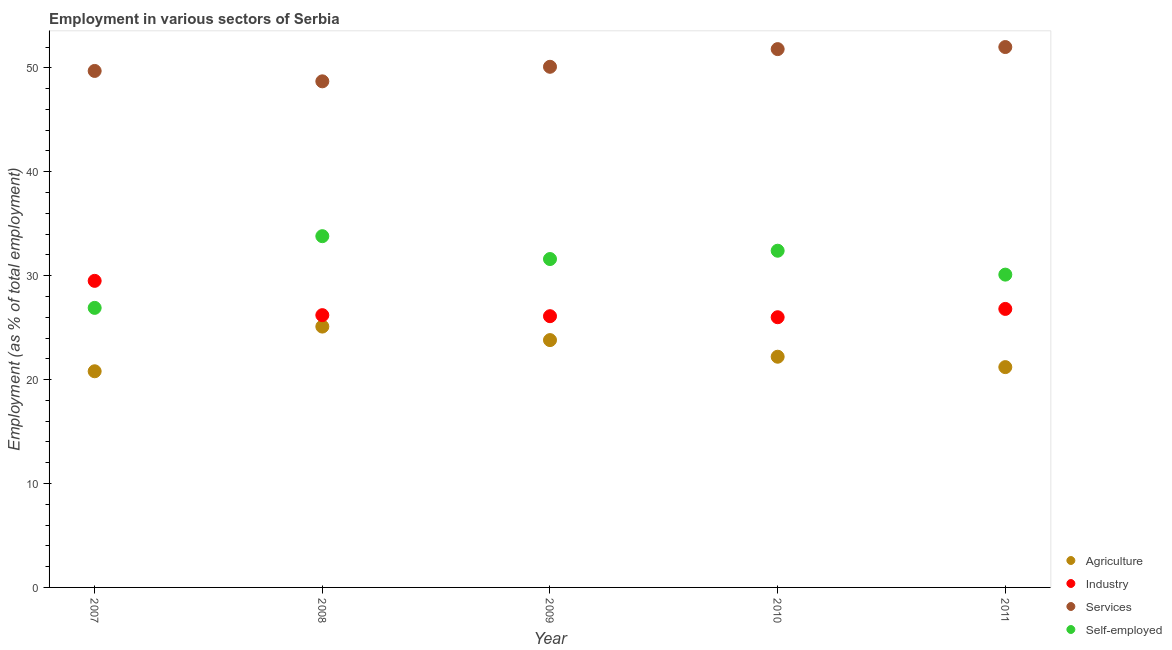How many different coloured dotlines are there?
Ensure brevity in your answer.  4. What is the percentage of workers in services in 2010?
Your response must be concise. 51.8. Across all years, what is the maximum percentage of self employed workers?
Make the answer very short. 33.8. In which year was the percentage of self employed workers maximum?
Offer a very short reply. 2008. What is the total percentage of workers in industry in the graph?
Ensure brevity in your answer.  134.6. What is the difference between the percentage of self employed workers in 2008 and that in 2010?
Your answer should be compact. 1.4. What is the difference between the percentage of workers in industry in 2011 and the percentage of workers in services in 2007?
Make the answer very short. -22.9. What is the average percentage of self employed workers per year?
Offer a very short reply. 30.96. In the year 2010, what is the difference between the percentage of workers in services and percentage of workers in agriculture?
Your answer should be very brief. 29.6. What is the ratio of the percentage of workers in agriculture in 2009 to that in 2010?
Your answer should be very brief. 1.07. What is the difference between the highest and the second highest percentage of self employed workers?
Make the answer very short. 1.4. What is the difference between the highest and the lowest percentage of workers in services?
Your response must be concise. 3.3. In how many years, is the percentage of workers in agriculture greater than the average percentage of workers in agriculture taken over all years?
Your answer should be very brief. 2. Is the sum of the percentage of self employed workers in 2010 and 2011 greater than the maximum percentage of workers in industry across all years?
Offer a terse response. Yes. Is it the case that in every year, the sum of the percentage of workers in services and percentage of workers in industry is greater than the sum of percentage of self employed workers and percentage of workers in agriculture?
Provide a succinct answer. No. Is it the case that in every year, the sum of the percentage of workers in agriculture and percentage of workers in industry is greater than the percentage of workers in services?
Ensure brevity in your answer.  No. Is the percentage of self employed workers strictly greater than the percentage of workers in services over the years?
Provide a succinct answer. No. Is the percentage of workers in industry strictly less than the percentage of workers in services over the years?
Offer a terse response. Yes. How many dotlines are there?
Your answer should be compact. 4. How many years are there in the graph?
Ensure brevity in your answer.  5. How many legend labels are there?
Provide a succinct answer. 4. What is the title of the graph?
Offer a terse response. Employment in various sectors of Serbia. Does "Secondary vocational education" appear as one of the legend labels in the graph?
Provide a short and direct response. No. What is the label or title of the Y-axis?
Make the answer very short. Employment (as % of total employment). What is the Employment (as % of total employment) of Agriculture in 2007?
Provide a succinct answer. 20.8. What is the Employment (as % of total employment) in Industry in 2007?
Keep it short and to the point. 29.5. What is the Employment (as % of total employment) in Services in 2007?
Offer a very short reply. 49.7. What is the Employment (as % of total employment) in Self-employed in 2007?
Offer a very short reply. 26.9. What is the Employment (as % of total employment) of Agriculture in 2008?
Keep it short and to the point. 25.1. What is the Employment (as % of total employment) of Industry in 2008?
Offer a terse response. 26.2. What is the Employment (as % of total employment) of Services in 2008?
Ensure brevity in your answer.  48.7. What is the Employment (as % of total employment) of Self-employed in 2008?
Keep it short and to the point. 33.8. What is the Employment (as % of total employment) of Agriculture in 2009?
Your response must be concise. 23.8. What is the Employment (as % of total employment) in Industry in 2009?
Provide a short and direct response. 26.1. What is the Employment (as % of total employment) in Services in 2009?
Give a very brief answer. 50.1. What is the Employment (as % of total employment) in Self-employed in 2009?
Your answer should be compact. 31.6. What is the Employment (as % of total employment) in Agriculture in 2010?
Provide a short and direct response. 22.2. What is the Employment (as % of total employment) of Industry in 2010?
Your answer should be very brief. 26. What is the Employment (as % of total employment) of Services in 2010?
Offer a terse response. 51.8. What is the Employment (as % of total employment) of Self-employed in 2010?
Your response must be concise. 32.4. What is the Employment (as % of total employment) in Agriculture in 2011?
Give a very brief answer. 21.2. What is the Employment (as % of total employment) of Industry in 2011?
Your answer should be very brief. 26.8. What is the Employment (as % of total employment) in Services in 2011?
Make the answer very short. 52. What is the Employment (as % of total employment) of Self-employed in 2011?
Keep it short and to the point. 30.1. Across all years, what is the maximum Employment (as % of total employment) in Agriculture?
Provide a short and direct response. 25.1. Across all years, what is the maximum Employment (as % of total employment) of Industry?
Provide a short and direct response. 29.5. Across all years, what is the maximum Employment (as % of total employment) of Self-employed?
Give a very brief answer. 33.8. Across all years, what is the minimum Employment (as % of total employment) in Agriculture?
Ensure brevity in your answer.  20.8. Across all years, what is the minimum Employment (as % of total employment) of Industry?
Make the answer very short. 26. Across all years, what is the minimum Employment (as % of total employment) in Services?
Provide a short and direct response. 48.7. Across all years, what is the minimum Employment (as % of total employment) in Self-employed?
Give a very brief answer. 26.9. What is the total Employment (as % of total employment) in Agriculture in the graph?
Your answer should be very brief. 113.1. What is the total Employment (as % of total employment) in Industry in the graph?
Give a very brief answer. 134.6. What is the total Employment (as % of total employment) in Services in the graph?
Give a very brief answer. 252.3. What is the total Employment (as % of total employment) in Self-employed in the graph?
Make the answer very short. 154.8. What is the difference between the Employment (as % of total employment) of Services in 2007 and that in 2008?
Offer a very short reply. 1. What is the difference between the Employment (as % of total employment) of Self-employed in 2007 and that in 2008?
Provide a short and direct response. -6.9. What is the difference between the Employment (as % of total employment) in Industry in 2007 and that in 2010?
Ensure brevity in your answer.  3.5. What is the difference between the Employment (as % of total employment) of Self-employed in 2007 and that in 2010?
Your response must be concise. -5.5. What is the difference between the Employment (as % of total employment) in Services in 2007 and that in 2011?
Offer a terse response. -2.3. What is the difference between the Employment (as % of total employment) of Services in 2008 and that in 2009?
Ensure brevity in your answer.  -1.4. What is the difference between the Employment (as % of total employment) of Agriculture in 2008 and that in 2010?
Ensure brevity in your answer.  2.9. What is the difference between the Employment (as % of total employment) in Self-employed in 2008 and that in 2010?
Provide a short and direct response. 1.4. What is the difference between the Employment (as % of total employment) in Agriculture in 2008 and that in 2011?
Provide a short and direct response. 3.9. What is the difference between the Employment (as % of total employment) in Industry in 2008 and that in 2011?
Provide a succinct answer. -0.6. What is the difference between the Employment (as % of total employment) of Self-employed in 2008 and that in 2011?
Provide a succinct answer. 3.7. What is the difference between the Employment (as % of total employment) of Agriculture in 2009 and that in 2010?
Offer a very short reply. 1.6. What is the difference between the Employment (as % of total employment) in Services in 2009 and that in 2010?
Provide a succinct answer. -1.7. What is the difference between the Employment (as % of total employment) in Self-employed in 2009 and that in 2010?
Keep it short and to the point. -0.8. What is the difference between the Employment (as % of total employment) of Agriculture in 2009 and that in 2011?
Offer a terse response. 2.6. What is the difference between the Employment (as % of total employment) of Industry in 2009 and that in 2011?
Your answer should be compact. -0.7. What is the difference between the Employment (as % of total employment) of Self-employed in 2009 and that in 2011?
Keep it short and to the point. 1.5. What is the difference between the Employment (as % of total employment) in Industry in 2010 and that in 2011?
Ensure brevity in your answer.  -0.8. What is the difference between the Employment (as % of total employment) of Services in 2010 and that in 2011?
Your response must be concise. -0.2. What is the difference between the Employment (as % of total employment) in Agriculture in 2007 and the Employment (as % of total employment) in Industry in 2008?
Provide a succinct answer. -5.4. What is the difference between the Employment (as % of total employment) of Agriculture in 2007 and the Employment (as % of total employment) of Services in 2008?
Provide a short and direct response. -27.9. What is the difference between the Employment (as % of total employment) in Agriculture in 2007 and the Employment (as % of total employment) in Self-employed in 2008?
Your response must be concise. -13. What is the difference between the Employment (as % of total employment) in Industry in 2007 and the Employment (as % of total employment) in Services in 2008?
Provide a short and direct response. -19.2. What is the difference between the Employment (as % of total employment) in Industry in 2007 and the Employment (as % of total employment) in Self-employed in 2008?
Ensure brevity in your answer.  -4.3. What is the difference between the Employment (as % of total employment) of Services in 2007 and the Employment (as % of total employment) of Self-employed in 2008?
Your response must be concise. 15.9. What is the difference between the Employment (as % of total employment) of Agriculture in 2007 and the Employment (as % of total employment) of Services in 2009?
Provide a short and direct response. -29.3. What is the difference between the Employment (as % of total employment) in Industry in 2007 and the Employment (as % of total employment) in Services in 2009?
Your answer should be very brief. -20.6. What is the difference between the Employment (as % of total employment) in Industry in 2007 and the Employment (as % of total employment) in Self-employed in 2009?
Your response must be concise. -2.1. What is the difference between the Employment (as % of total employment) in Services in 2007 and the Employment (as % of total employment) in Self-employed in 2009?
Ensure brevity in your answer.  18.1. What is the difference between the Employment (as % of total employment) in Agriculture in 2007 and the Employment (as % of total employment) in Services in 2010?
Ensure brevity in your answer.  -31. What is the difference between the Employment (as % of total employment) in Industry in 2007 and the Employment (as % of total employment) in Services in 2010?
Provide a succinct answer. -22.3. What is the difference between the Employment (as % of total employment) in Industry in 2007 and the Employment (as % of total employment) in Self-employed in 2010?
Ensure brevity in your answer.  -2.9. What is the difference between the Employment (as % of total employment) of Services in 2007 and the Employment (as % of total employment) of Self-employed in 2010?
Your answer should be compact. 17.3. What is the difference between the Employment (as % of total employment) of Agriculture in 2007 and the Employment (as % of total employment) of Industry in 2011?
Offer a terse response. -6. What is the difference between the Employment (as % of total employment) in Agriculture in 2007 and the Employment (as % of total employment) in Services in 2011?
Your answer should be compact. -31.2. What is the difference between the Employment (as % of total employment) of Agriculture in 2007 and the Employment (as % of total employment) of Self-employed in 2011?
Ensure brevity in your answer.  -9.3. What is the difference between the Employment (as % of total employment) of Industry in 2007 and the Employment (as % of total employment) of Services in 2011?
Offer a terse response. -22.5. What is the difference between the Employment (as % of total employment) of Industry in 2007 and the Employment (as % of total employment) of Self-employed in 2011?
Ensure brevity in your answer.  -0.6. What is the difference between the Employment (as % of total employment) of Services in 2007 and the Employment (as % of total employment) of Self-employed in 2011?
Your answer should be very brief. 19.6. What is the difference between the Employment (as % of total employment) of Agriculture in 2008 and the Employment (as % of total employment) of Services in 2009?
Keep it short and to the point. -25. What is the difference between the Employment (as % of total employment) of Agriculture in 2008 and the Employment (as % of total employment) of Self-employed in 2009?
Offer a terse response. -6.5. What is the difference between the Employment (as % of total employment) in Industry in 2008 and the Employment (as % of total employment) in Services in 2009?
Ensure brevity in your answer.  -23.9. What is the difference between the Employment (as % of total employment) in Agriculture in 2008 and the Employment (as % of total employment) in Industry in 2010?
Provide a succinct answer. -0.9. What is the difference between the Employment (as % of total employment) of Agriculture in 2008 and the Employment (as % of total employment) of Services in 2010?
Keep it short and to the point. -26.7. What is the difference between the Employment (as % of total employment) in Industry in 2008 and the Employment (as % of total employment) in Services in 2010?
Ensure brevity in your answer.  -25.6. What is the difference between the Employment (as % of total employment) of Agriculture in 2008 and the Employment (as % of total employment) of Services in 2011?
Provide a short and direct response. -26.9. What is the difference between the Employment (as % of total employment) of Agriculture in 2008 and the Employment (as % of total employment) of Self-employed in 2011?
Your answer should be compact. -5. What is the difference between the Employment (as % of total employment) in Industry in 2008 and the Employment (as % of total employment) in Services in 2011?
Your answer should be compact. -25.8. What is the difference between the Employment (as % of total employment) of Services in 2008 and the Employment (as % of total employment) of Self-employed in 2011?
Your answer should be very brief. 18.6. What is the difference between the Employment (as % of total employment) of Industry in 2009 and the Employment (as % of total employment) of Services in 2010?
Keep it short and to the point. -25.7. What is the difference between the Employment (as % of total employment) in Agriculture in 2009 and the Employment (as % of total employment) in Industry in 2011?
Provide a succinct answer. -3. What is the difference between the Employment (as % of total employment) of Agriculture in 2009 and the Employment (as % of total employment) of Services in 2011?
Your answer should be compact. -28.2. What is the difference between the Employment (as % of total employment) in Agriculture in 2009 and the Employment (as % of total employment) in Self-employed in 2011?
Your answer should be compact. -6.3. What is the difference between the Employment (as % of total employment) of Industry in 2009 and the Employment (as % of total employment) of Services in 2011?
Provide a short and direct response. -25.9. What is the difference between the Employment (as % of total employment) of Agriculture in 2010 and the Employment (as % of total employment) of Industry in 2011?
Give a very brief answer. -4.6. What is the difference between the Employment (as % of total employment) of Agriculture in 2010 and the Employment (as % of total employment) of Services in 2011?
Your response must be concise. -29.8. What is the difference between the Employment (as % of total employment) of Industry in 2010 and the Employment (as % of total employment) of Self-employed in 2011?
Your response must be concise. -4.1. What is the difference between the Employment (as % of total employment) in Services in 2010 and the Employment (as % of total employment) in Self-employed in 2011?
Provide a succinct answer. 21.7. What is the average Employment (as % of total employment) of Agriculture per year?
Your answer should be very brief. 22.62. What is the average Employment (as % of total employment) of Industry per year?
Give a very brief answer. 26.92. What is the average Employment (as % of total employment) in Services per year?
Provide a short and direct response. 50.46. What is the average Employment (as % of total employment) of Self-employed per year?
Provide a short and direct response. 30.96. In the year 2007, what is the difference between the Employment (as % of total employment) of Agriculture and Employment (as % of total employment) of Services?
Make the answer very short. -28.9. In the year 2007, what is the difference between the Employment (as % of total employment) of Agriculture and Employment (as % of total employment) of Self-employed?
Ensure brevity in your answer.  -6.1. In the year 2007, what is the difference between the Employment (as % of total employment) in Industry and Employment (as % of total employment) in Services?
Offer a terse response. -20.2. In the year 2007, what is the difference between the Employment (as % of total employment) of Industry and Employment (as % of total employment) of Self-employed?
Your response must be concise. 2.6. In the year 2007, what is the difference between the Employment (as % of total employment) in Services and Employment (as % of total employment) in Self-employed?
Your answer should be compact. 22.8. In the year 2008, what is the difference between the Employment (as % of total employment) of Agriculture and Employment (as % of total employment) of Industry?
Your answer should be compact. -1.1. In the year 2008, what is the difference between the Employment (as % of total employment) in Agriculture and Employment (as % of total employment) in Services?
Keep it short and to the point. -23.6. In the year 2008, what is the difference between the Employment (as % of total employment) of Agriculture and Employment (as % of total employment) of Self-employed?
Provide a short and direct response. -8.7. In the year 2008, what is the difference between the Employment (as % of total employment) of Industry and Employment (as % of total employment) of Services?
Make the answer very short. -22.5. In the year 2008, what is the difference between the Employment (as % of total employment) of Industry and Employment (as % of total employment) of Self-employed?
Make the answer very short. -7.6. In the year 2008, what is the difference between the Employment (as % of total employment) of Services and Employment (as % of total employment) of Self-employed?
Keep it short and to the point. 14.9. In the year 2009, what is the difference between the Employment (as % of total employment) of Agriculture and Employment (as % of total employment) of Services?
Your response must be concise. -26.3. In the year 2010, what is the difference between the Employment (as % of total employment) of Agriculture and Employment (as % of total employment) of Industry?
Offer a very short reply. -3.8. In the year 2010, what is the difference between the Employment (as % of total employment) in Agriculture and Employment (as % of total employment) in Services?
Make the answer very short. -29.6. In the year 2010, what is the difference between the Employment (as % of total employment) in Agriculture and Employment (as % of total employment) in Self-employed?
Your answer should be compact. -10.2. In the year 2010, what is the difference between the Employment (as % of total employment) in Industry and Employment (as % of total employment) in Services?
Your response must be concise. -25.8. In the year 2010, what is the difference between the Employment (as % of total employment) in Industry and Employment (as % of total employment) in Self-employed?
Your response must be concise. -6.4. In the year 2010, what is the difference between the Employment (as % of total employment) in Services and Employment (as % of total employment) in Self-employed?
Make the answer very short. 19.4. In the year 2011, what is the difference between the Employment (as % of total employment) in Agriculture and Employment (as % of total employment) in Services?
Keep it short and to the point. -30.8. In the year 2011, what is the difference between the Employment (as % of total employment) in Industry and Employment (as % of total employment) in Services?
Your response must be concise. -25.2. In the year 2011, what is the difference between the Employment (as % of total employment) in Industry and Employment (as % of total employment) in Self-employed?
Your answer should be very brief. -3.3. In the year 2011, what is the difference between the Employment (as % of total employment) in Services and Employment (as % of total employment) in Self-employed?
Your response must be concise. 21.9. What is the ratio of the Employment (as % of total employment) in Agriculture in 2007 to that in 2008?
Offer a terse response. 0.83. What is the ratio of the Employment (as % of total employment) of Industry in 2007 to that in 2008?
Provide a succinct answer. 1.13. What is the ratio of the Employment (as % of total employment) in Services in 2007 to that in 2008?
Provide a succinct answer. 1.02. What is the ratio of the Employment (as % of total employment) in Self-employed in 2007 to that in 2008?
Your response must be concise. 0.8. What is the ratio of the Employment (as % of total employment) of Agriculture in 2007 to that in 2009?
Provide a succinct answer. 0.87. What is the ratio of the Employment (as % of total employment) in Industry in 2007 to that in 2009?
Ensure brevity in your answer.  1.13. What is the ratio of the Employment (as % of total employment) of Services in 2007 to that in 2009?
Offer a terse response. 0.99. What is the ratio of the Employment (as % of total employment) of Self-employed in 2007 to that in 2009?
Provide a short and direct response. 0.85. What is the ratio of the Employment (as % of total employment) of Agriculture in 2007 to that in 2010?
Provide a succinct answer. 0.94. What is the ratio of the Employment (as % of total employment) of Industry in 2007 to that in 2010?
Make the answer very short. 1.13. What is the ratio of the Employment (as % of total employment) of Services in 2007 to that in 2010?
Give a very brief answer. 0.96. What is the ratio of the Employment (as % of total employment) in Self-employed in 2007 to that in 2010?
Provide a succinct answer. 0.83. What is the ratio of the Employment (as % of total employment) in Agriculture in 2007 to that in 2011?
Offer a very short reply. 0.98. What is the ratio of the Employment (as % of total employment) of Industry in 2007 to that in 2011?
Give a very brief answer. 1.1. What is the ratio of the Employment (as % of total employment) of Services in 2007 to that in 2011?
Offer a very short reply. 0.96. What is the ratio of the Employment (as % of total employment) of Self-employed in 2007 to that in 2011?
Offer a terse response. 0.89. What is the ratio of the Employment (as % of total employment) in Agriculture in 2008 to that in 2009?
Your answer should be compact. 1.05. What is the ratio of the Employment (as % of total employment) in Services in 2008 to that in 2009?
Your answer should be compact. 0.97. What is the ratio of the Employment (as % of total employment) in Self-employed in 2008 to that in 2009?
Your answer should be very brief. 1.07. What is the ratio of the Employment (as % of total employment) of Agriculture in 2008 to that in 2010?
Keep it short and to the point. 1.13. What is the ratio of the Employment (as % of total employment) of Industry in 2008 to that in 2010?
Provide a short and direct response. 1.01. What is the ratio of the Employment (as % of total employment) of Services in 2008 to that in 2010?
Make the answer very short. 0.94. What is the ratio of the Employment (as % of total employment) of Self-employed in 2008 to that in 2010?
Offer a very short reply. 1.04. What is the ratio of the Employment (as % of total employment) of Agriculture in 2008 to that in 2011?
Your answer should be very brief. 1.18. What is the ratio of the Employment (as % of total employment) in Industry in 2008 to that in 2011?
Offer a terse response. 0.98. What is the ratio of the Employment (as % of total employment) in Services in 2008 to that in 2011?
Provide a succinct answer. 0.94. What is the ratio of the Employment (as % of total employment) in Self-employed in 2008 to that in 2011?
Keep it short and to the point. 1.12. What is the ratio of the Employment (as % of total employment) of Agriculture in 2009 to that in 2010?
Your response must be concise. 1.07. What is the ratio of the Employment (as % of total employment) of Services in 2009 to that in 2010?
Your answer should be very brief. 0.97. What is the ratio of the Employment (as % of total employment) in Self-employed in 2009 to that in 2010?
Ensure brevity in your answer.  0.98. What is the ratio of the Employment (as % of total employment) of Agriculture in 2009 to that in 2011?
Give a very brief answer. 1.12. What is the ratio of the Employment (as % of total employment) of Industry in 2009 to that in 2011?
Keep it short and to the point. 0.97. What is the ratio of the Employment (as % of total employment) of Services in 2009 to that in 2011?
Give a very brief answer. 0.96. What is the ratio of the Employment (as % of total employment) in Self-employed in 2009 to that in 2011?
Your response must be concise. 1.05. What is the ratio of the Employment (as % of total employment) in Agriculture in 2010 to that in 2011?
Your answer should be compact. 1.05. What is the ratio of the Employment (as % of total employment) of Industry in 2010 to that in 2011?
Provide a succinct answer. 0.97. What is the ratio of the Employment (as % of total employment) in Services in 2010 to that in 2011?
Provide a succinct answer. 1. What is the ratio of the Employment (as % of total employment) in Self-employed in 2010 to that in 2011?
Your answer should be compact. 1.08. What is the difference between the highest and the second highest Employment (as % of total employment) in Agriculture?
Provide a short and direct response. 1.3. What is the difference between the highest and the second highest Employment (as % of total employment) of Industry?
Your answer should be compact. 2.7. What is the difference between the highest and the second highest Employment (as % of total employment) of Services?
Keep it short and to the point. 0.2. What is the difference between the highest and the second highest Employment (as % of total employment) of Self-employed?
Give a very brief answer. 1.4. What is the difference between the highest and the lowest Employment (as % of total employment) in Agriculture?
Offer a terse response. 4.3. What is the difference between the highest and the lowest Employment (as % of total employment) of Self-employed?
Make the answer very short. 6.9. 